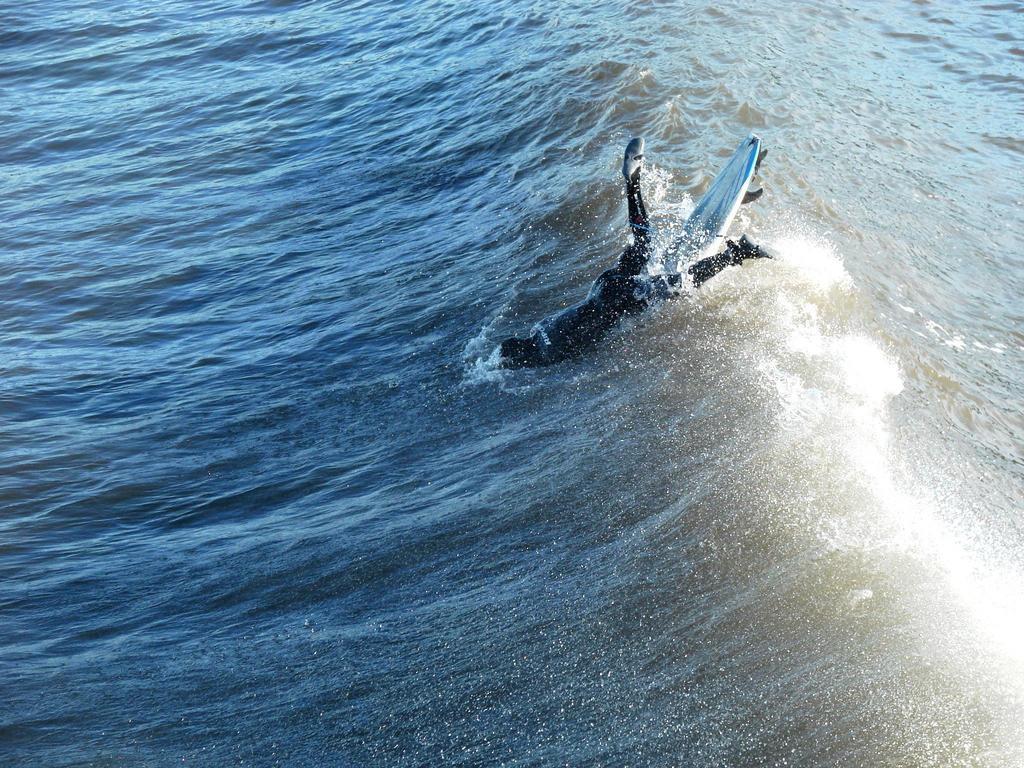How would you summarize this image in a sentence or two? In this image I can see the person with the surfboard and I can see the person in the water. I can see the water in blue color. 